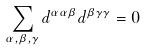<formula> <loc_0><loc_0><loc_500><loc_500>\sum _ { \alpha , \beta , \gamma } d ^ { \alpha \alpha \beta } d ^ { \beta \gamma \gamma } = 0</formula> 